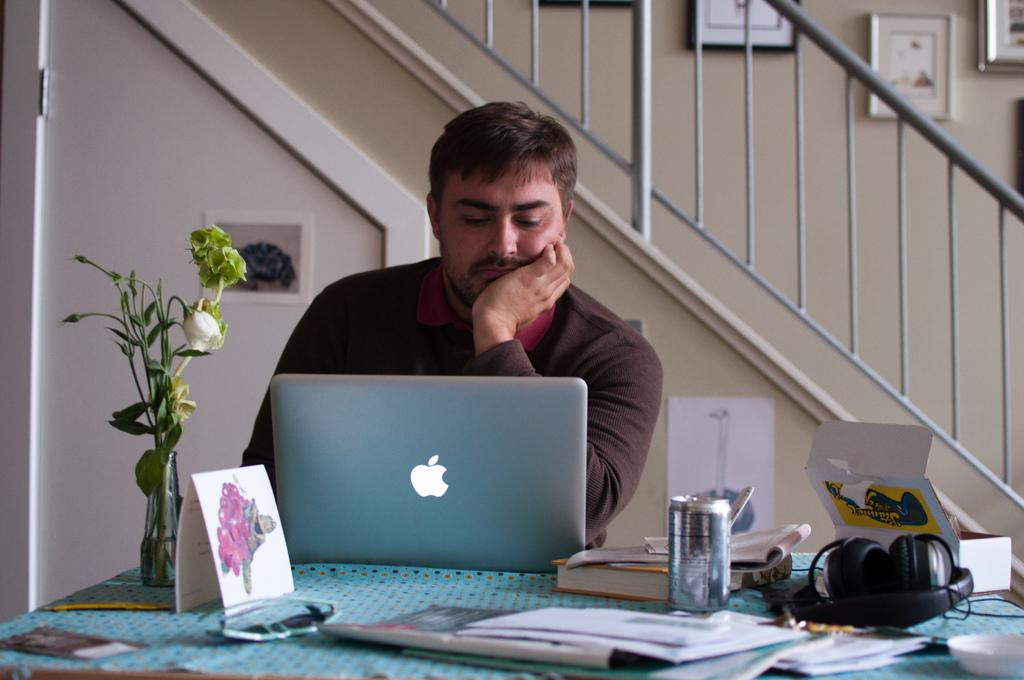What is the color of the wall in the image? The wall in the image is white. What can be seen on the wall? There is a photo frame on the wall. What type of furniture is present in the image? There is a chair and a table in the image. What is the man in the image doing? The man is sitting on the chair. What items are on the table? There is a laptop, a flask, papers, a headset, and a tin on the table. How many accounts does the man have on his laptop in the image? The number of accounts on the man's laptop cannot be determined from the image. Is there a water source visible in the image? There is no water source visible in the image. 